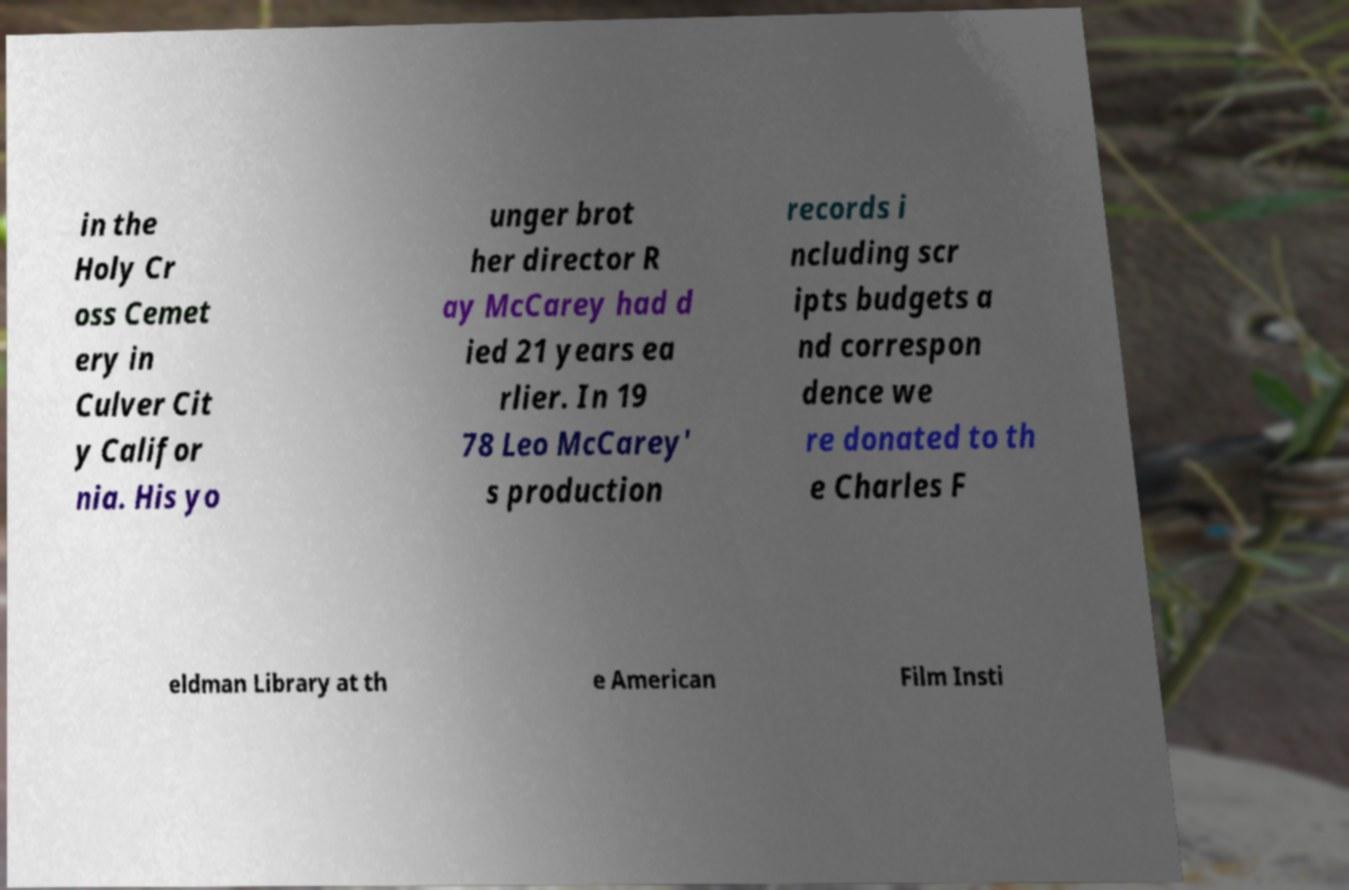Could you assist in decoding the text presented in this image and type it out clearly? in the Holy Cr oss Cemet ery in Culver Cit y Califor nia. His yo unger brot her director R ay McCarey had d ied 21 years ea rlier. In 19 78 Leo McCarey' s production records i ncluding scr ipts budgets a nd correspon dence we re donated to th e Charles F eldman Library at th e American Film Insti 